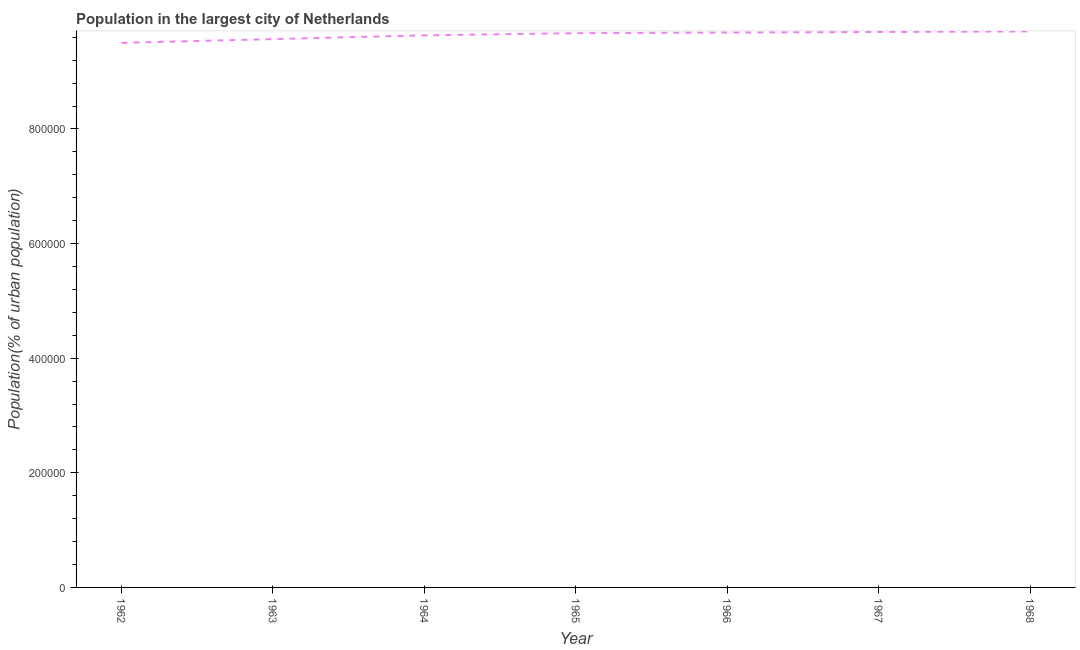What is the population in largest city in 1964?
Your answer should be very brief. 9.63e+05. Across all years, what is the maximum population in largest city?
Make the answer very short. 9.70e+05. Across all years, what is the minimum population in largest city?
Provide a succinct answer. 9.50e+05. In which year was the population in largest city maximum?
Your answer should be very brief. 1968. What is the sum of the population in largest city?
Provide a succinct answer. 6.75e+06. What is the difference between the population in largest city in 1963 and 1965?
Provide a succinct answer. -1.04e+04. What is the average population in largest city per year?
Ensure brevity in your answer.  9.64e+05. What is the median population in largest city?
Make the answer very short. 9.67e+05. In how many years, is the population in largest city greater than 800000 %?
Keep it short and to the point. 7. What is the ratio of the population in largest city in 1967 to that in 1968?
Give a very brief answer. 1. Is the population in largest city in 1963 less than that in 1966?
Offer a terse response. Yes. What is the difference between the highest and the second highest population in largest city?
Keep it short and to the point. 1033. Is the sum of the population in largest city in 1962 and 1963 greater than the maximum population in largest city across all years?
Ensure brevity in your answer.  Yes. What is the difference between the highest and the lowest population in largest city?
Offer a very short reply. 1.99e+04. Does the population in largest city monotonically increase over the years?
Your answer should be compact. Yes. What is the difference between two consecutive major ticks on the Y-axis?
Make the answer very short. 2.00e+05. Are the values on the major ticks of Y-axis written in scientific E-notation?
Your answer should be compact. No. Does the graph contain grids?
Your response must be concise. No. What is the title of the graph?
Provide a short and direct response. Population in the largest city of Netherlands. What is the label or title of the Y-axis?
Your response must be concise. Population(% of urban population). What is the Population(% of urban population) of 1962?
Provide a succinct answer. 9.50e+05. What is the Population(% of urban population) of 1963?
Your answer should be compact. 9.57e+05. What is the Population(% of urban population) of 1964?
Your answer should be compact. 9.63e+05. What is the Population(% of urban population) of 1965?
Your answer should be very brief. 9.67e+05. What is the Population(% of urban population) of 1966?
Provide a succinct answer. 9.68e+05. What is the Population(% of urban population) in 1967?
Provide a short and direct response. 9.69e+05. What is the Population(% of urban population) in 1968?
Give a very brief answer. 9.70e+05. What is the difference between the Population(% of urban population) in 1962 and 1963?
Offer a very short reply. -6490. What is the difference between the Population(% of urban population) in 1962 and 1964?
Provide a short and direct response. -1.30e+04. What is the difference between the Population(% of urban population) in 1962 and 1965?
Offer a terse response. -1.68e+04. What is the difference between the Population(% of urban population) in 1962 and 1966?
Keep it short and to the point. -1.79e+04. What is the difference between the Population(% of urban population) in 1962 and 1967?
Keep it short and to the point. -1.89e+04. What is the difference between the Population(% of urban population) in 1962 and 1968?
Provide a short and direct response. -1.99e+04. What is the difference between the Population(% of urban population) in 1963 and 1964?
Make the answer very short. -6543. What is the difference between the Population(% of urban population) in 1963 and 1965?
Ensure brevity in your answer.  -1.04e+04. What is the difference between the Population(% of urban population) in 1963 and 1966?
Your response must be concise. -1.14e+04. What is the difference between the Population(% of urban population) in 1963 and 1967?
Give a very brief answer. -1.24e+04. What is the difference between the Population(% of urban population) in 1963 and 1968?
Offer a terse response. -1.34e+04. What is the difference between the Population(% of urban population) in 1964 and 1965?
Your response must be concise. -3812. What is the difference between the Population(% of urban population) in 1964 and 1966?
Make the answer very short. -4840. What is the difference between the Population(% of urban population) in 1964 and 1967?
Your response must be concise. -5870. What is the difference between the Population(% of urban population) in 1964 and 1968?
Your answer should be very brief. -6903. What is the difference between the Population(% of urban population) in 1965 and 1966?
Provide a short and direct response. -1028. What is the difference between the Population(% of urban population) in 1965 and 1967?
Keep it short and to the point. -2058. What is the difference between the Population(% of urban population) in 1965 and 1968?
Give a very brief answer. -3091. What is the difference between the Population(% of urban population) in 1966 and 1967?
Make the answer very short. -1030. What is the difference between the Population(% of urban population) in 1966 and 1968?
Your response must be concise. -2063. What is the difference between the Population(% of urban population) in 1967 and 1968?
Offer a terse response. -1033. What is the ratio of the Population(% of urban population) in 1962 to that in 1966?
Ensure brevity in your answer.  0.98. What is the ratio of the Population(% of urban population) in 1962 to that in 1967?
Ensure brevity in your answer.  0.98. What is the ratio of the Population(% of urban population) in 1962 to that in 1968?
Make the answer very short. 0.98. What is the ratio of the Population(% of urban population) in 1963 to that in 1964?
Keep it short and to the point. 0.99. What is the ratio of the Population(% of urban population) in 1963 to that in 1967?
Give a very brief answer. 0.99. What is the ratio of the Population(% of urban population) in 1965 to that in 1966?
Your answer should be very brief. 1. What is the ratio of the Population(% of urban population) in 1965 to that in 1968?
Give a very brief answer. 1. What is the ratio of the Population(% of urban population) in 1967 to that in 1968?
Offer a very short reply. 1. 